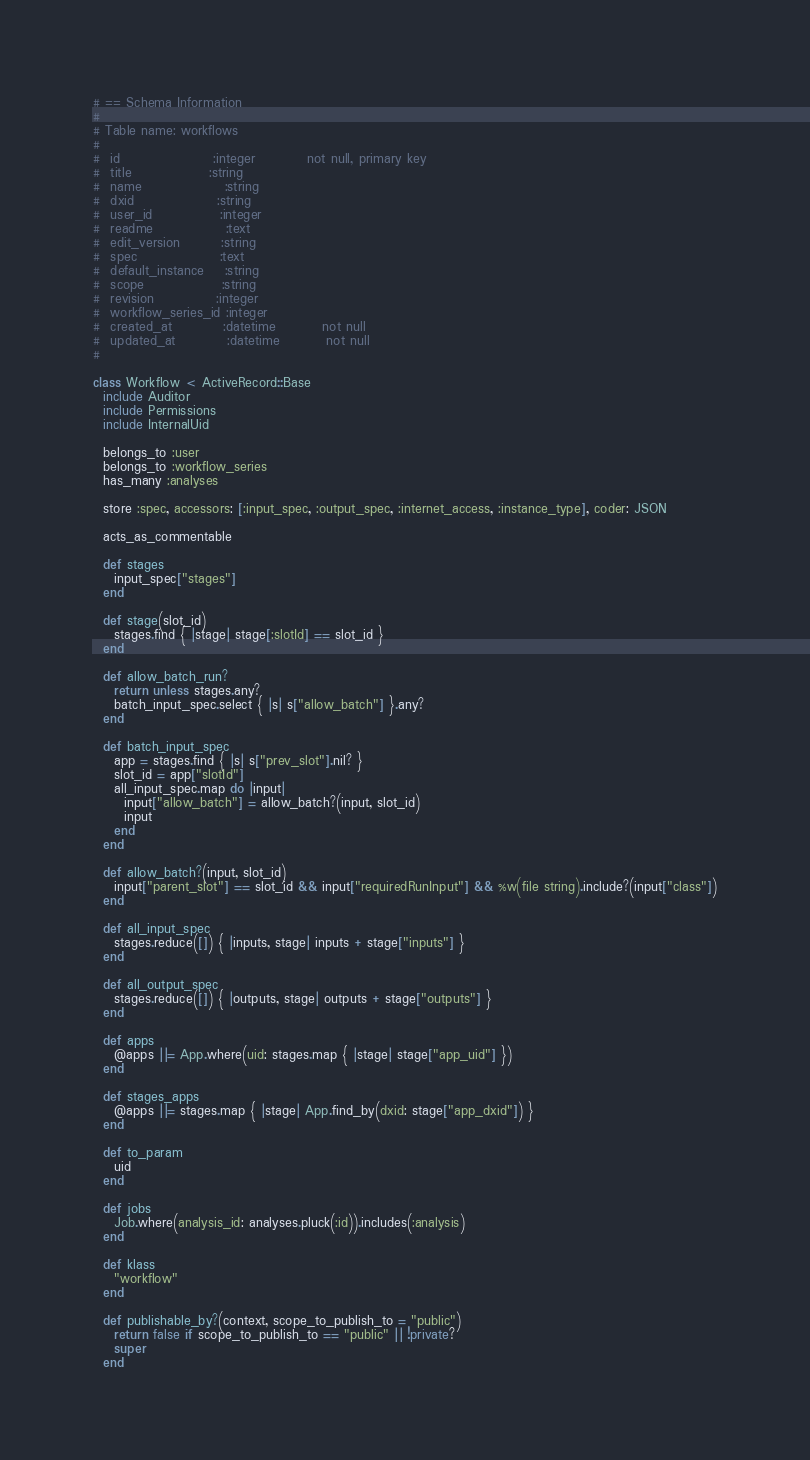<code> <loc_0><loc_0><loc_500><loc_500><_Ruby_># == Schema Information
#
# Table name: workflows
#
#  id                  :integer          not null, primary key
#  title               :string
#  name                :string
#  dxid                :string
#  user_id             :integer
#  readme              :text
#  edit_version        :string
#  spec                :text
#  default_instance    :string
#  scope               :string
#  revision            :integer
#  workflow_series_id :integer
#  created_at          :datetime         not null
#  updated_at          :datetime         not null
#

class Workflow < ActiveRecord::Base
  include Auditor
  include Permissions
  include InternalUid

  belongs_to :user
  belongs_to :workflow_series
  has_many :analyses

  store :spec, accessors: [:input_spec, :output_spec, :internet_access, :instance_type], coder: JSON

  acts_as_commentable

  def stages
    input_spec["stages"]
  end

  def stage(slot_id)
    stages.find { |stage| stage[:slotId] == slot_id }
  end

  def allow_batch_run?
    return unless stages.any?
    batch_input_spec.select { |s| s["allow_batch"] }.any?
  end

  def batch_input_spec
    app = stages.find { |s| s["prev_slot"].nil? }
    slot_id = app["slotId"]
    all_input_spec.map do |input|
      input["allow_batch"] = allow_batch?(input, slot_id)
      input
    end
  end

  def allow_batch?(input, slot_id)
    input["parent_slot"] == slot_id && input["requiredRunInput"] && %w(file string).include?(input["class"])
  end

  def all_input_spec
    stages.reduce([]) { |inputs, stage| inputs + stage["inputs"] }
  end

  def all_output_spec
    stages.reduce([]) { |outputs, stage| outputs + stage["outputs"] }
  end

  def apps
    @apps ||= App.where(uid: stages.map { |stage| stage["app_uid"] })
  end

  def stages_apps
    @apps ||= stages.map { |stage| App.find_by(dxid: stage["app_dxid"]) }
  end

  def to_param
    uid
  end

  def jobs
    Job.where(analysis_id: analyses.pluck(:id)).includes(:analysis)
  end

  def klass
    "workflow"
  end

  def publishable_by?(context, scope_to_publish_to = "public")
    return false if scope_to_publish_to == "public" || !private?
    super
  end
</code> 